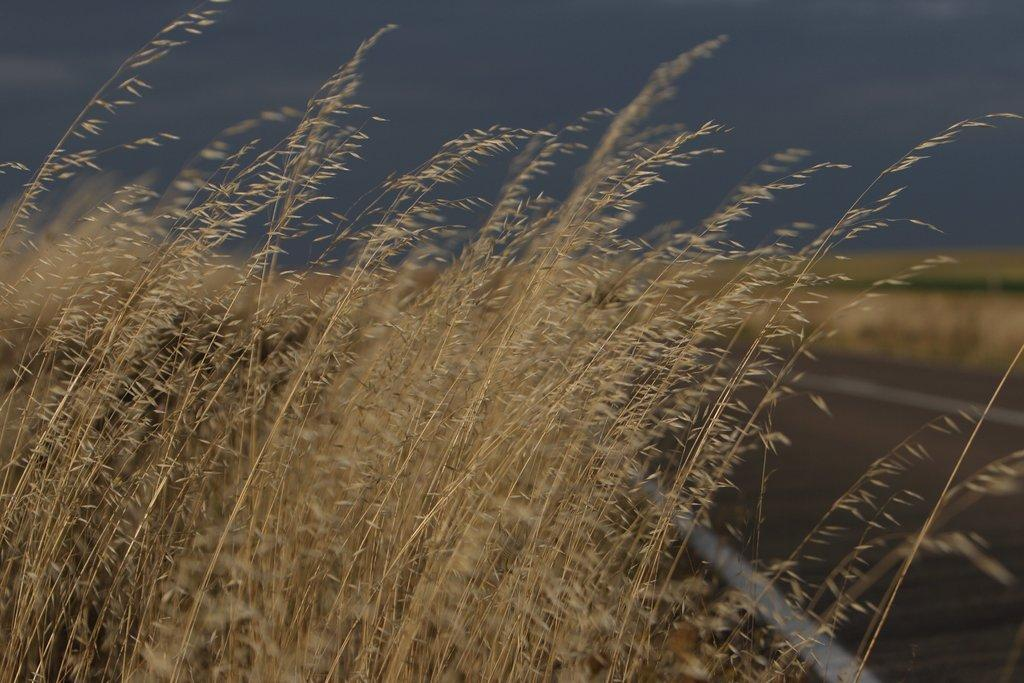What type of vegetation can be seen in the image? There is dried grass in the image. What else is present in the image besides the dried grass? There is a road in the image. What type of muscle is being exercised by the person in the image? There is no person present in the image, so it is not possible to determine which muscle is being exercised. 